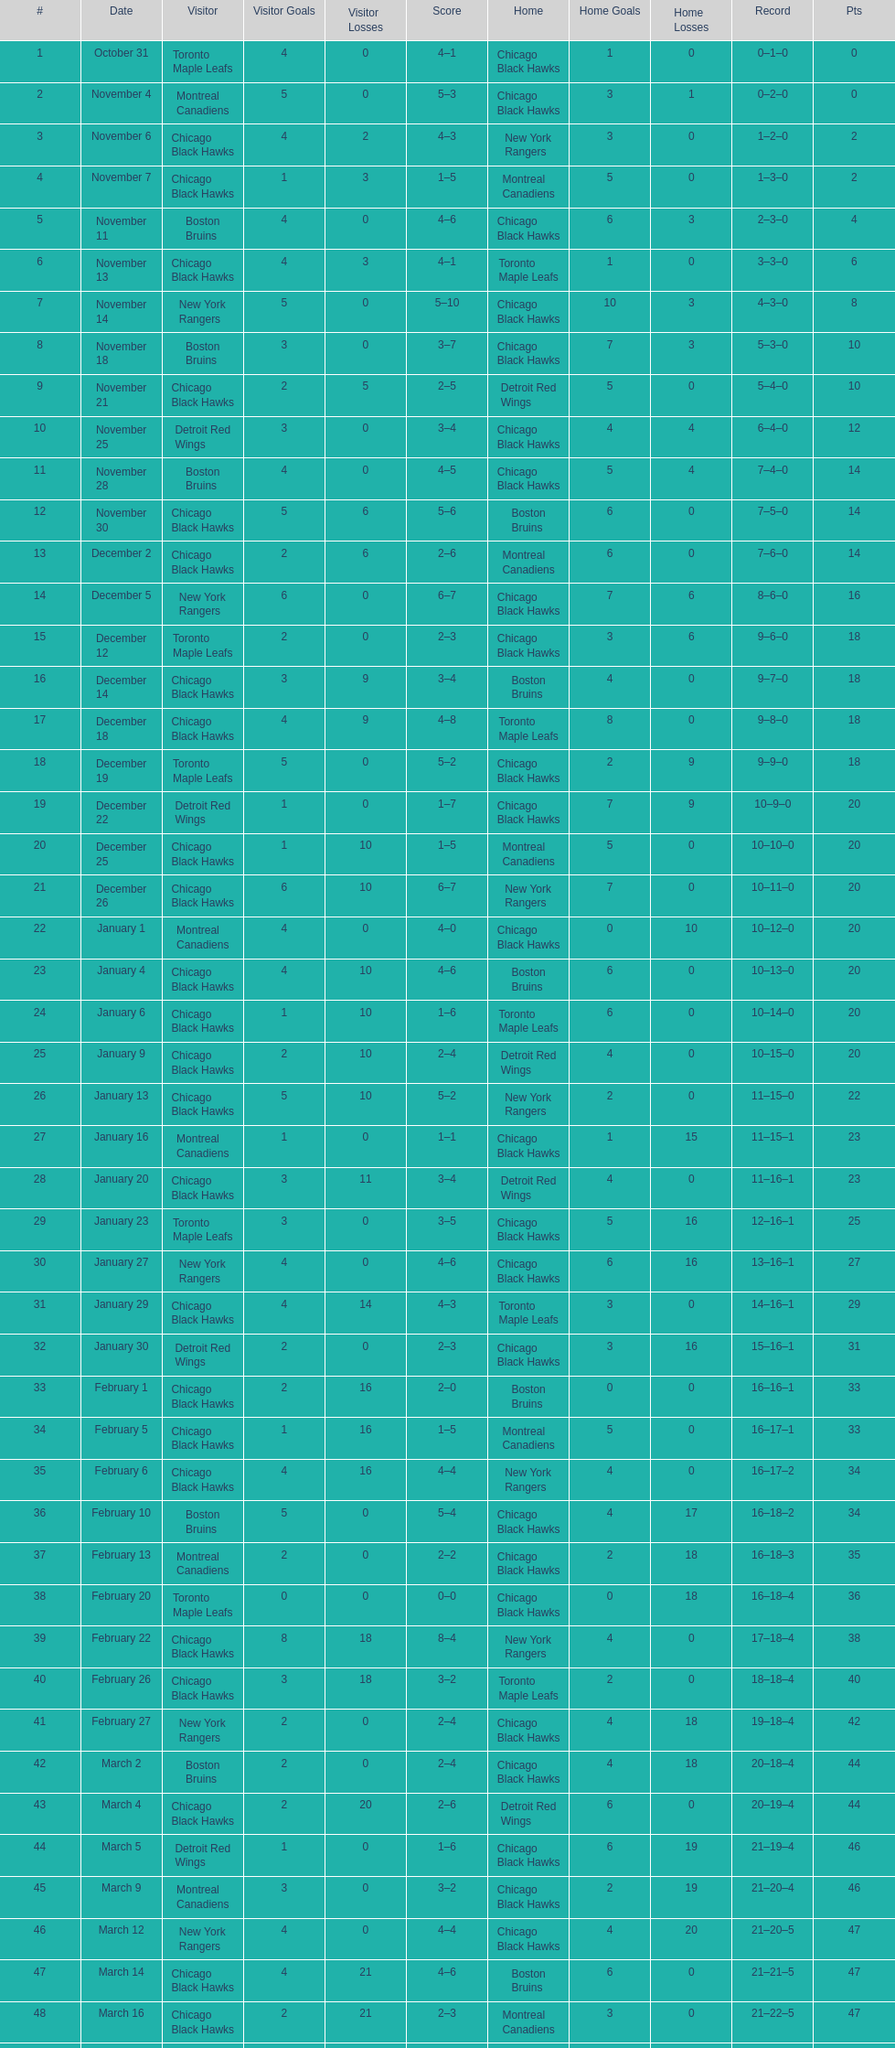Which team was the first one the black hawks lost to? Toronto Maple Leafs. 